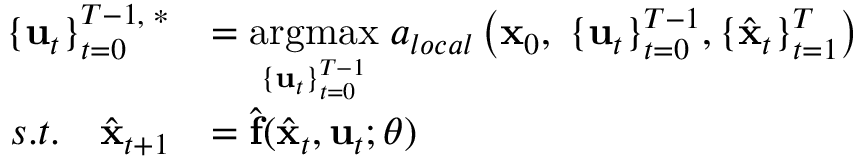Convert formula to latex. <formula><loc_0><loc_0><loc_500><loc_500>\begin{array} { r l } { \{ u _ { t } \} _ { t = 0 } ^ { T - 1 , \, * } } & { = \underset { \{ u _ { t } \} _ { t = 0 } ^ { T - 1 } } { \arg \max } \, a _ { l o c a l } \left ( x _ { 0 } , \, \{ u _ { t } \} _ { t = 0 } ^ { T - 1 } , \{ \hat { x } _ { t } \} _ { t = 1 } ^ { T } \right ) } \\ { s . t . \quad \hat { x } _ { t + 1 } } & { = \hat { f } ( \hat { x } _ { t } , u _ { t } ; \theta ) } \end{array}</formula> 